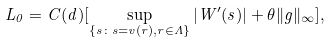Convert formula to latex. <formula><loc_0><loc_0><loc_500><loc_500>L _ { 0 } = C ( d ) [ \sup _ { \{ s \colon s = v ( r ) , r \in \Lambda \} } | W ^ { \prime } ( s ) | + \theta \| g \| _ { \infty } ] ,</formula> 